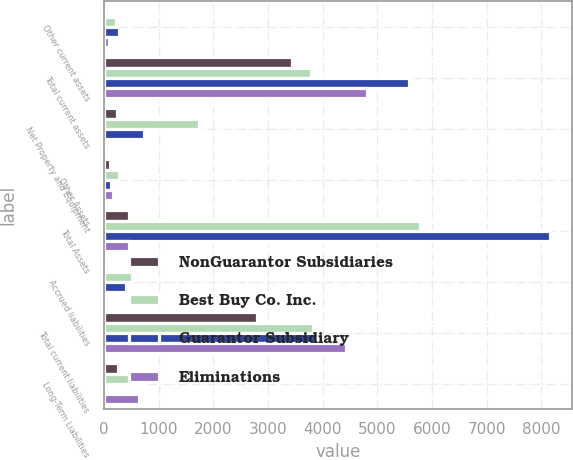Convert chart to OTSL. <chart><loc_0><loc_0><loc_500><loc_500><stacked_bar_chart><ecel><fcel>Other current assets<fcel>Total current assets<fcel>Net Property and Equipment<fcel>Other Assets<fcel>Total Assets<fcel>Accrued liabilities<fcel>Total current liabilities<fcel>Long-Term Liabilities<nl><fcel>NonGuarantor Subsidiaries<fcel>20<fcel>3441<fcel>244<fcel>108<fcel>455<fcel>7<fcel>2801<fcel>257<nl><fcel>Best Buy Co. Inc.<fcel>211<fcel>3782<fcel>1733<fcel>266<fcel>5787<fcel>518<fcel>3816<fcel>732<nl><fcel>Guarantor Subsidiary<fcel>265<fcel>5577<fcel>737<fcel>131<fcel>8164<fcel>392<fcel>3872<fcel>31<nl><fcel>Eliminations<fcel>87<fcel>4815<fcel>2<fcel>157<fcel>455<fcel>39<fcel>4433<fcel>647<nl></chart> 